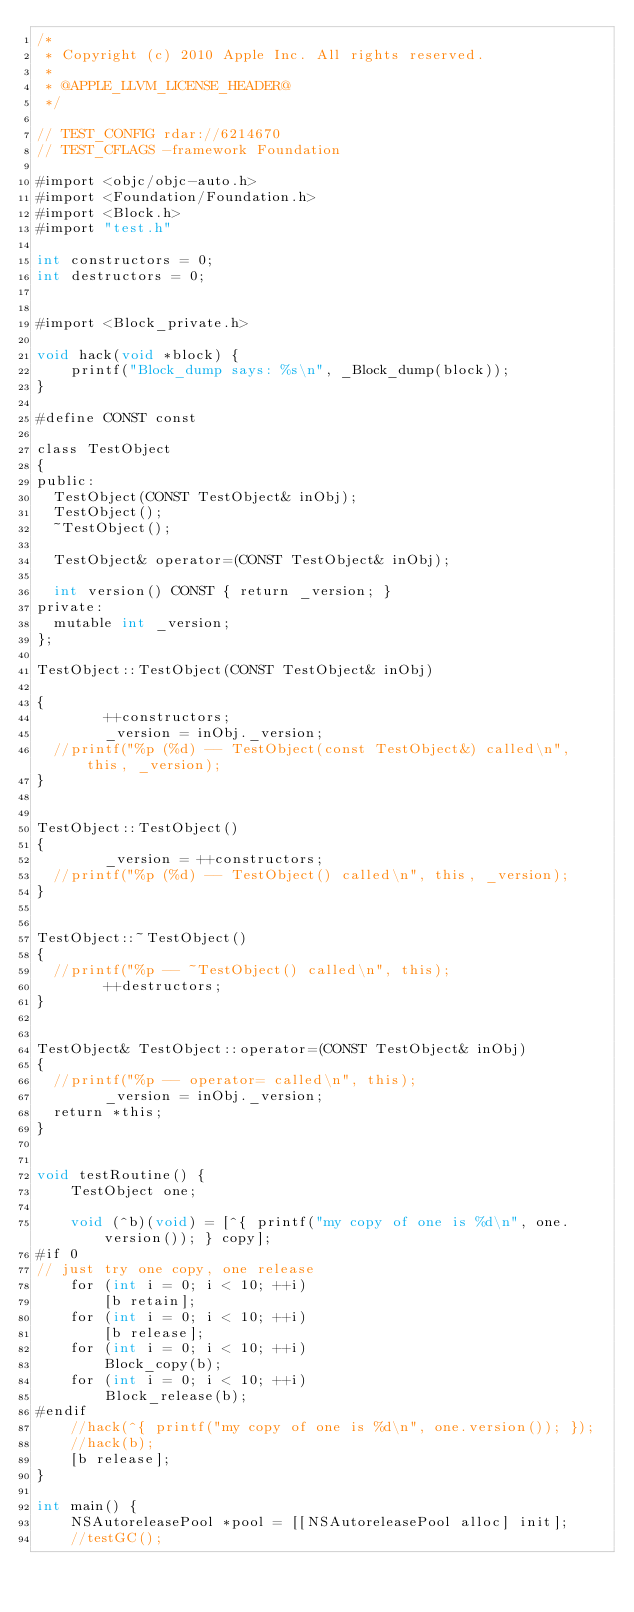<code> <loc_0><loc_0><loc_500><loc_500><_ObjectiveC_>/*
 * Copyright (c) 2010 Apple Inc. All rights reserved.
 *
 * @APPLE_LLVM_LICENSE_HEADER@
 */

// TEST_CONFIG rdar://6214670
// TEST_CFLAGS -framework Foundation

#import <objc/objc-auto.h>
#import <Foundation/Foundation.h>
#import <Block.h>
#import "test.h"

int constructors = 0;
int destructors = 0;


#import <Block_private.h>

void hack(void *block) {
    printf("Block_dump says: %s\n", _Block_dump(block));
}

#define CONST const

class TestObject
{
public:
	TestObject(CONST TestObject& inObj);
	TestObject();
	~TestObject();
	
	TestObject& operator=(CONST TestObject& inObj);

	int version() CONST { return _version; }
private:
	mutable int _version;
};

TestObject::TestObject(CONST TestObject& inObj)
	
{
        ++constructors;
        _version = inObj._version;
	//printf("%p (%d) -- TestObject(const TestObject&) called\n", this, _version); 
}


TestObject::TestObject()
{
        _version = ++constructors;
	//printf("%p (%d) -- TestObject() called\n", this, _version); 
}


TestObject::~TestObject()
{
	//printf("%p -- ~TestObject() called\n", this);
        ++destructors;
}


TestObject& TestObject::operator=(CONST TestObject& inObj)
{
	//printf("%p -- operator= called\n", this);
        _version = inObj._version;
	return *this;
}


void testRoutine() {
    TestObject one;
    
    void (^b)(void) = [^{ printf("my copy of one is %d\n", one.version()); } copy];
#if 0
// just try one copy, one release
    for (int i = 0; i < 10; ++i)
        [b retain];
    for (int i = 0; i < 10; ++i)
        [b release];
    for (int i = 0; i < 10; ++i)
        Block_copy(b);
    for (int i = 0; i < 10; ++i)
        Block_release(b);
#endif
    //hack(^{ printf("my copy of one is %d\n", one.version()); });
    //hack(b);
    [b release];
}

int main() {
    NSAutoreleasePool *pool = [[NSAutoreleasePool alloc] init];
    //testGC();</code> 